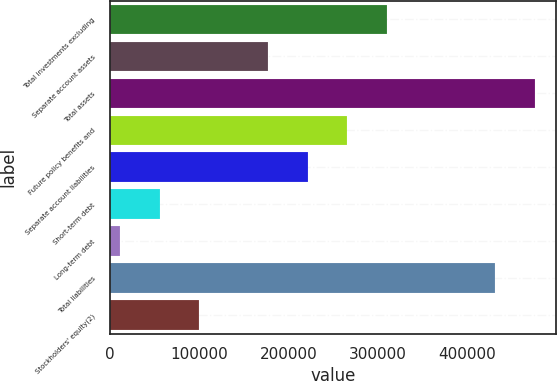Convert chart. <chart><loc_0><loc_0><loc_500><loc_500><bar_chart><fcel>Total investments excluding<fcel>Separate account assets<fcel>Total assets<fcel>Future policy benefits and<fcel>Separate account liabilities<fcel>Short-term debt<fcel>Long-term debt<fcel>Total liabilities<fcel>Stockholders' equity(2)<nl><fcel>310316<fcel>177463<fcel>475658<fcel>266032<fcel>221747<fcel>55707.3<fcel>11423<fcel>431374<fcel>99991.6<nl></chart> 